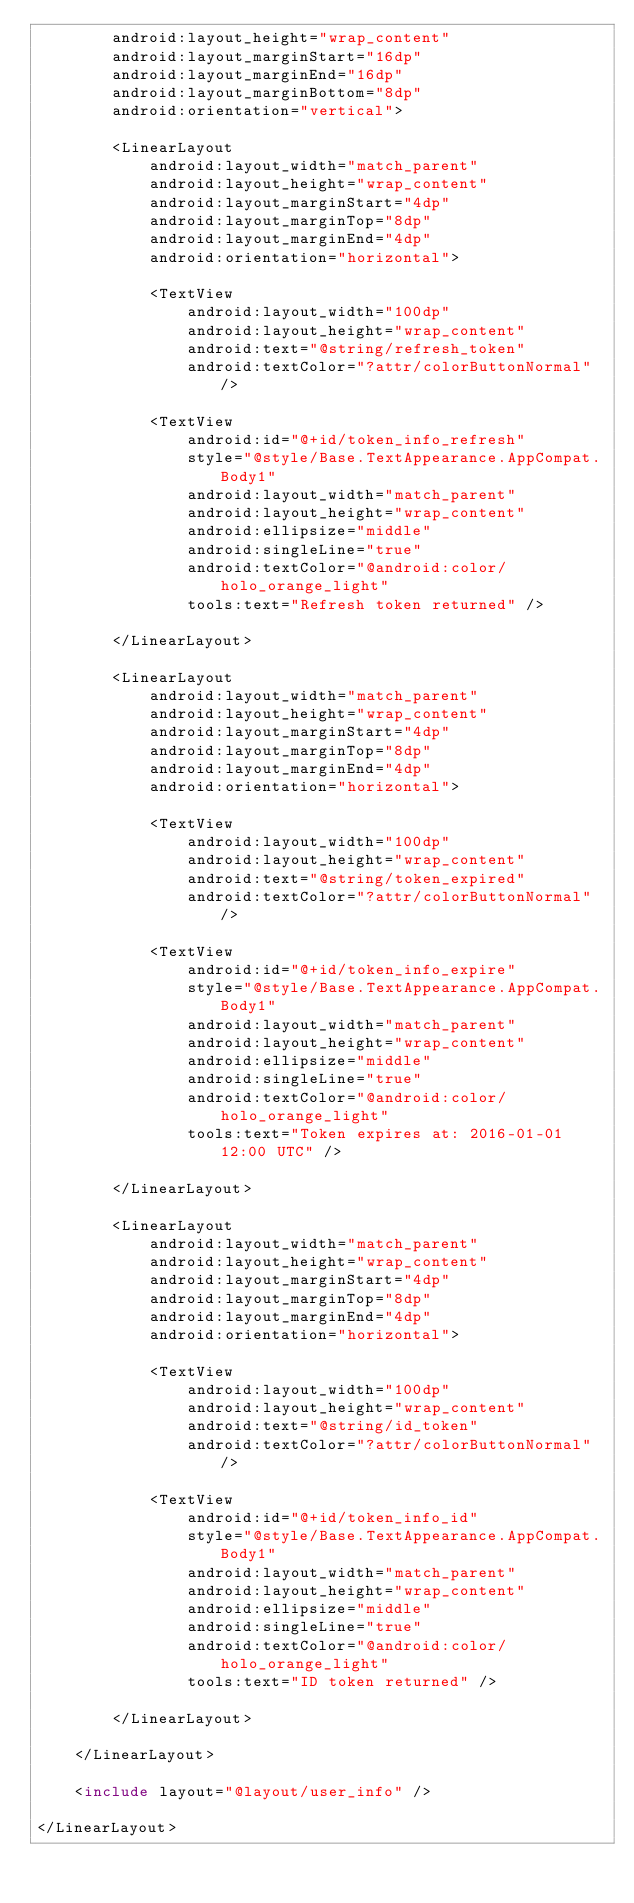<code> <loc_0><loc_0><loc_500><loc_500><_XML_>        android:layout_height="wrap_content"
        android:layout_marginStart="16dp"
        android:layout_marginEnd="16dp"
        android:layout_marginBottom="8dp"
        android:orientation="vertical">

        <LinearLayout
            android:layout_width="match_parent"
            android:layout_height="wrap_content"
            android:layout_marginStart="4dp"
            android:layout_marginTop="8dp"
            android:layout_marginEnd="4dp"
            android:orientation="horizontal">

            <TextView
                android:layout_width="100dp"
                android:layout_height="wrap_content"
                android:text="@string/refresh_token"
                android:textColor="?attr/colorButtonNormal" />

            <TextView
                android:id="@+id/token_info_refresh"
                style="@style/Base.TextAppearance.AppCompat.Body1"
                android:layout_width="match_parent"
                android:layout_height="wrap_content"
                android:ellipsize="middle"
                android:singleLine="true"
                android:textColor="@android:color/holo_orange_light"
                tools:text="Refresh token returned" />

        </LinearLayout>

        <LinearLayout
            android:layout_width="match_parent"
            android:layout_height="wrap_content"
            android:layout_marginStart="4dp"
            android:layout_marginTop="8dp"
            android:layout_marginEnd="4dp"
            android:orientation="horizontal">

            <TextView
                android:layout_width="100dp"
                android:layout_height="wrap_content"
                android:text="@string/token_expired"
                android:textColor="?attr/colorButtonNormal" />

            <TextView
                android:id="@+id/token_info_expire"
                style="@style/Base.TextAppearance.AppCompat.Body1"
                android:layout_width="match_parent"
                android:layout_height="wrap_content"
                android:ellipsize="middle"
                android:singleLine="true"
                android:textColor="@android:color/holo_orange_light"
                tools:text="Token expires at: 2016-01-01 12:00 UTC" />

        </LinearLayout>

        <LinearLayout
            android:layout_width="match_parent"
            android:layout_height="wrap_content"
            android:layout_marginStart="4dp"
            android:layout_marginTop="8dp"
            android:layout_marginEnd="4dp"
            android:orientation="horizontal">

            <TextView
                android:layout_width="100dp"
                android:layout_height="wrap_content"
                android:text="@string/id_token"
                android:textColor="?attr/colorButtonNormal" />

            <TextView
                android:id="@+id/token_info_id"
                style="@style/Base.TextAppearance.AppCompat.Body1"
                android:layout_width="match_parent"
                android:layout_height="wrap_content"
                android:ellipsize="middle"
                android:singleLine="true"
                android:textColor="@android:color/holo_orange_light"
                tools:text="ID token returned" />

        </LinearLayout>

    </LinearLayout>

    <include layout="@layout/user_info" />

</LinearLayout></code> 